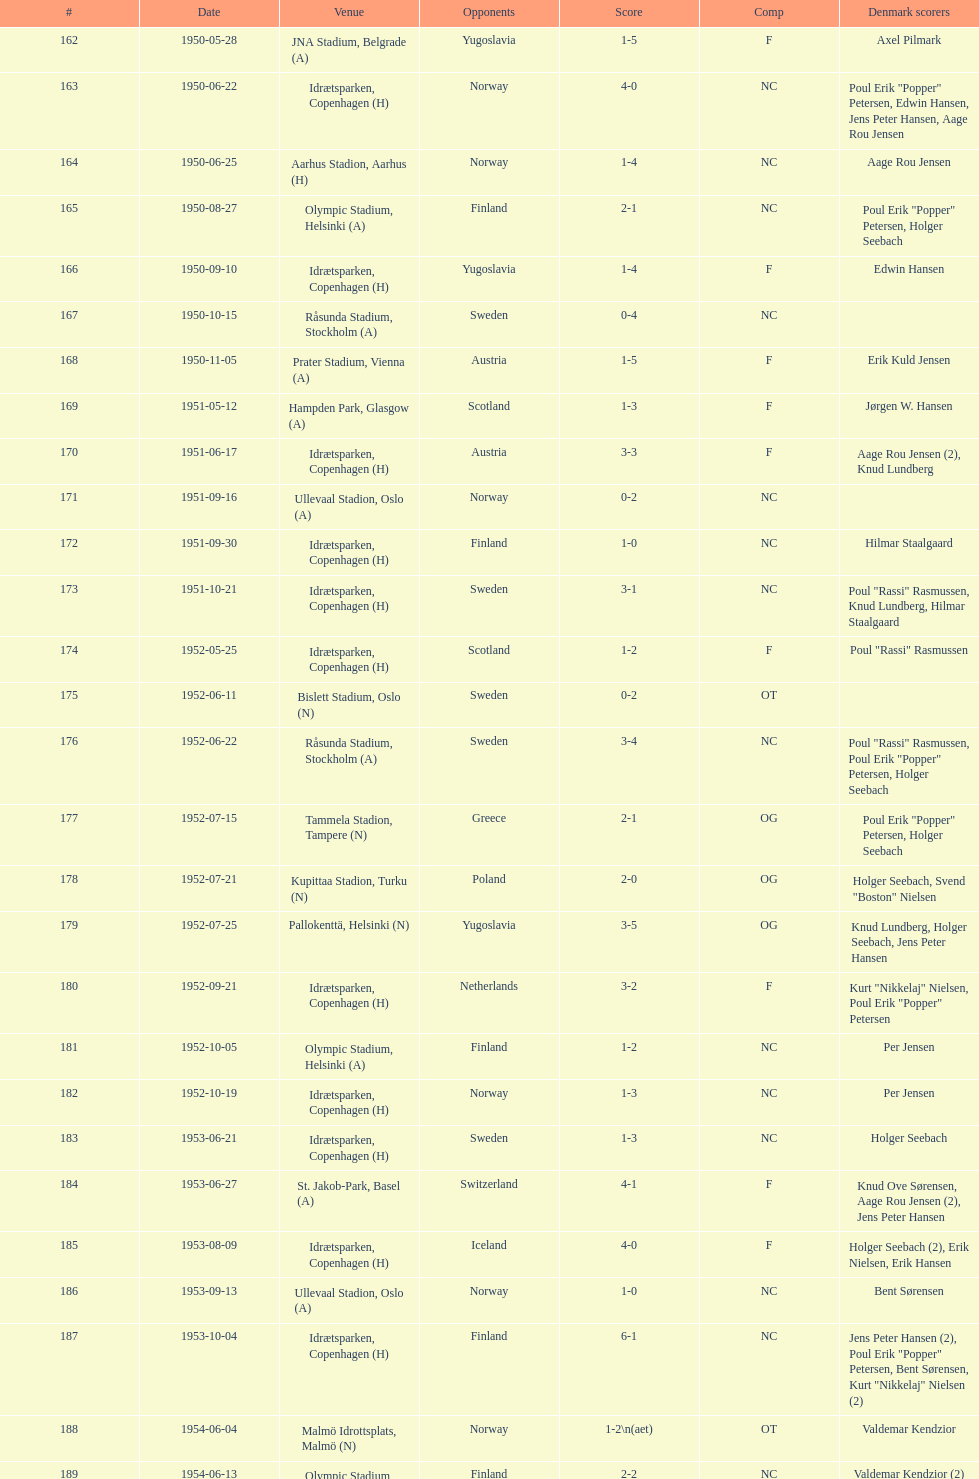What is the designation of the place recorded before olympic stadium on 1950-08-27? Aarhus Stadion, Aarhus. 